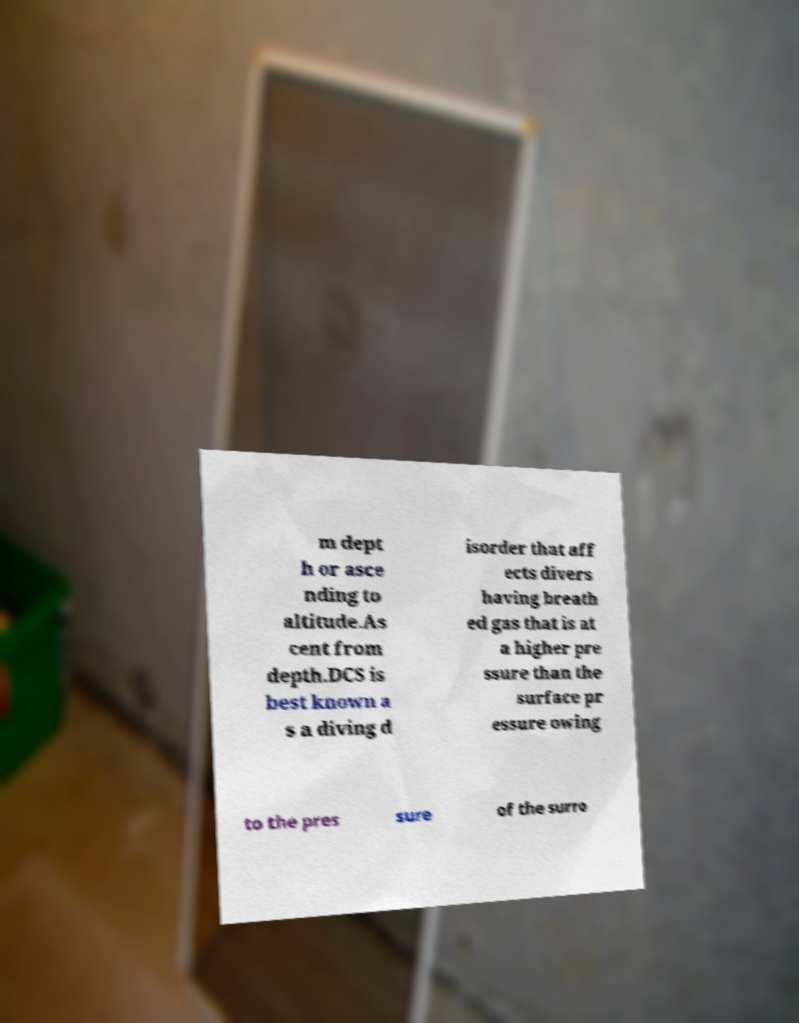I need the written content from this picture converted into text. Can you do that? m dept h or asce nding to altitude.As cent from depth.DCS is best known a s a diving d isorder that aff ects divers having breath ed gas that is at a higher pre ssure than the surface pr essure owing to the pres sure of the surro 